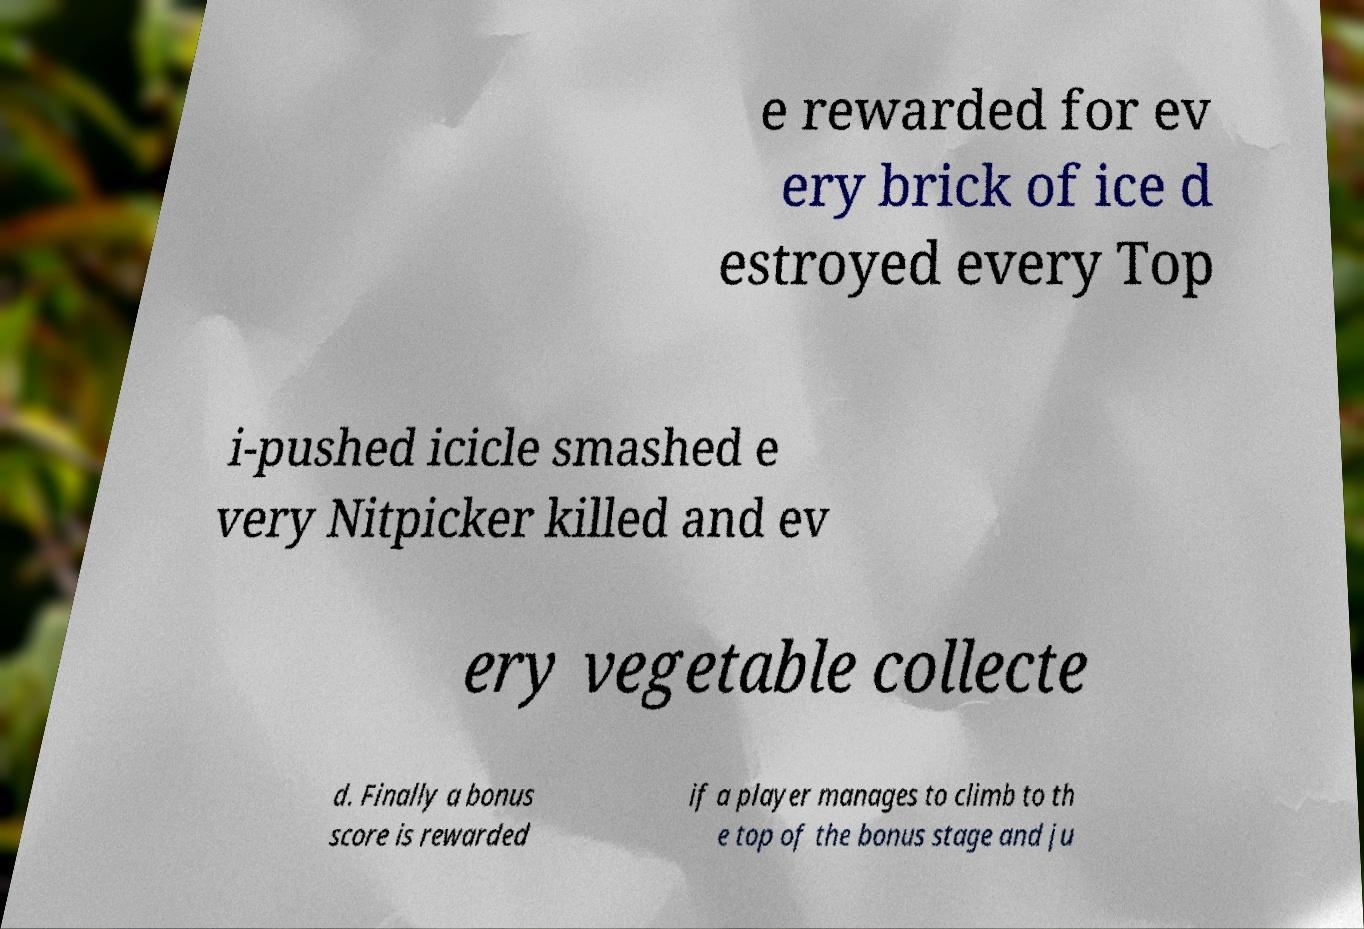For documentation purposes, I need the text within this image transcribed. Could you provide that? e rewarded for ev ery brick of ice d estroyed every Top i-pushed icicle smashed e very Nitpicker killed and ev ery vegetable collecte d. Finally a bonus score is rewarded if a player manages to climb to th e top of the bonus stage and ju 